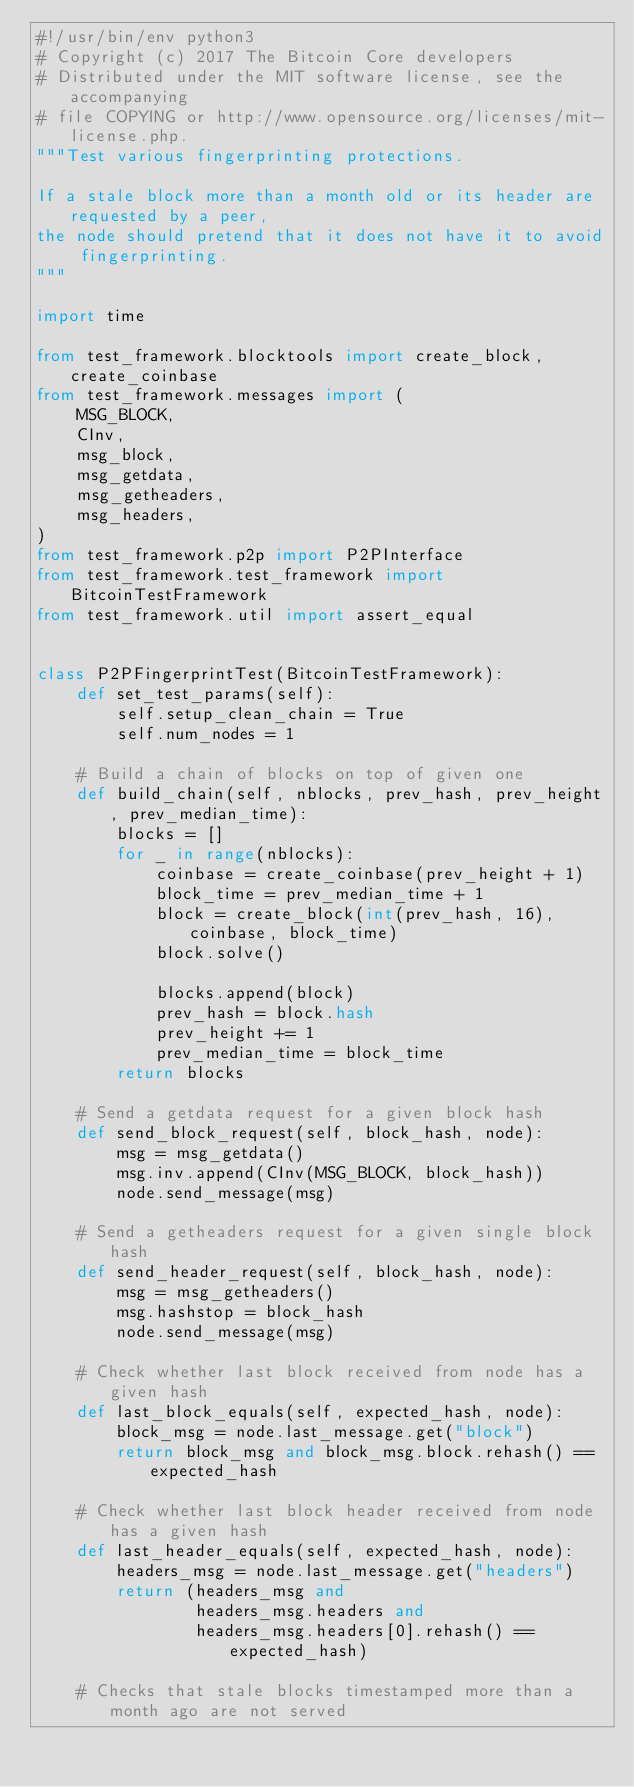Convert code to text. <code><loc_0><loc_0><loc_500><loc_500><_Python_>#!/usr/bin/env python3
# Copyright (c) 2017 The Bitcoin Core developers
# Distributed under the MIT software license, see the accompanying
# file COPYING or http://www.opensource.org/licenses/mit-license.php.
"""Test various fingerprinting protections.

If a stale block more than a month old or its header are requested by a peer,
the node should pretend that it does not have it to avoid fingerprinting.
"""

import time

from test_framework.blocktools import create_block, create_coinbase
from test_framework.messages import (
    MSG_BLOCK,
    CInv,
    msg_block,
    msg_getdata,
    msg_getheaders,
    msg_headers,
)
from test_framework.p2p import P2PInterface
from test_framework.test_framework import BitcoinTestFramework
from test_framework.util import assert_equal


class P2PFingerprintTest(BitcoinTestFramework):
    def set_test_params(self):
        self.setup_clean_chain = True
        self.num_nodes = 1

    # Build a chain of blocks on top of given one
    def build_chain(self, nblocks, prev_hash, prev_height, prev_median_time):
        blocks = []
        for _ in range(nblocks):
            coinbase = create_coinbase(prev_height + 1)
            block_time = prev_median_time + 1
            block = create_block(int(prev_hash, 16), coinbase, block_time)
            block.solve()

            blocks.append(block)
            prev_hash = block.hash
            prev_height += 1
            prev_median_time = block_time
        return blocks

    # Send a getdata request for a given block hash
    def send_block_request(self, block_hash, node):
        msg = msg_getdata()
        msg.inv.append(CInv(MSG_BLOCK, block_hash))
        node.send_message(msg)

    # Send a getheaders request for a given single block hash
    def send_header_request(self, block_hash, node):
        msg = msg_getheaders()
        msg.hashstop = block_hash
        node.send_message(msg)

    # Check whether last block received from node has a given hash
    def last_block_equals(self, expected_hash, node):
        block_msg = node.last_message.get("block")
        return block_msg and block_msg.block.rehash() == expected_hash

    # Check whether last block header received from node has a given hash
    def last_header_equals(self, expected_hash, node):
        headers_msg = node.last_message.get("headers")
        return (headers_msg and
                headers_msg.headers and
                headers_msg.headers[0].rehash() == expected_hash)

    # Checks that stale blocks timestamped more than a month ago are not served</code> 